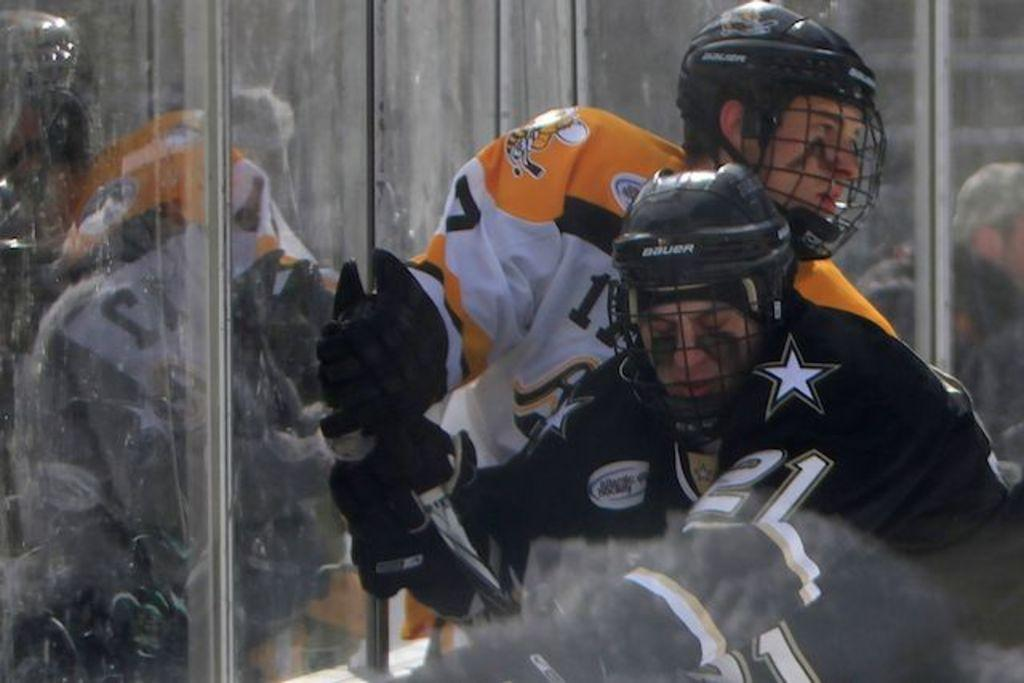What type of people are in the image? There are men in the image. What protective gear are the men wearing? The men are wearing gloves and helmets. What type of popcorn is being served at the event in the image? There is no event or popcorn present in the image; it features men wearing gloves and helmets. What is the account balance of the person in the image? There is no reference to an account or balance in the image, as it focuses on the men and their protective gear. 